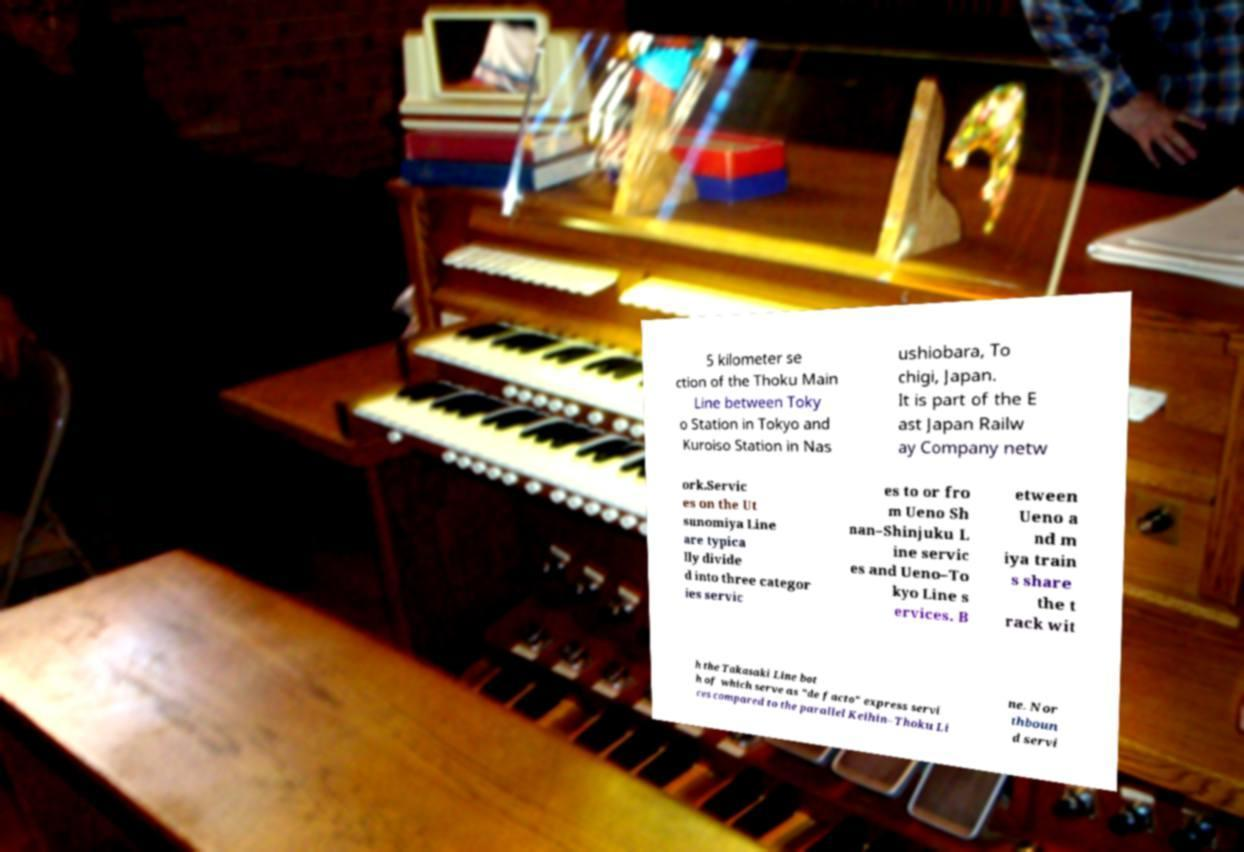Could you extract and type out the text from this image? 5 kilometer se ction of the Thoku Main Line between Toky o Station in Tokyo and Kuroiso Station in Nas ushiobara, To chigi, Japan. It is part of the E ast Japan Railw ay Company netw ork.Servic es on the Ut sunomiya Line are typica lly divide d into three categor ies servic es to or fro m Ueno Sh nan–Shinjuku L ine servic es and Ueno–To kyo Line s ervices. B etween Ueno a nd m iya train s share the t rack wit h the Takasaki Line bot h of which serve as "de facto" express servi ces compared to the parallel Keihin–Thoku Li ne. Nor thboun d servi 